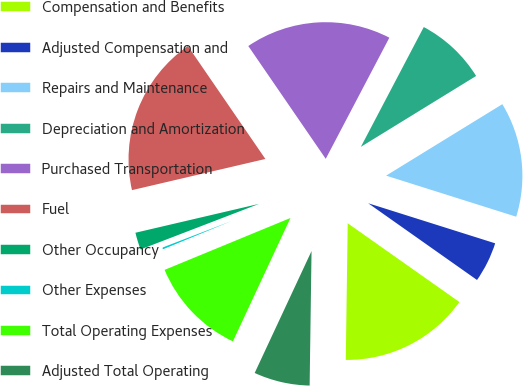Convert chart to OTSL. <chart><loc_0><loc_0><loc_500><loc_500><pie_chart><fcel>Compensation and Benefits<fcel>Adjusted Compensation and<fcel>Repairs and Maintenance<fcel>Depreciation and Amortization<fcel>Purchased Transportation<fcel>Fuel<fcel>Other Occupancy<fcel>Other Expenses<fcel>Total Operating Expenses<fcel>Adjusted Total Operating<nl><fcel>15.45%<fcel>4.91%<fcel>13.64%<fcel>8.53%<fcel>17.27%<fcel>19.08%<fcel>2.19%<fcel>0.38%<fcel>11.83%<fcel>6.72%<nl></chart> 